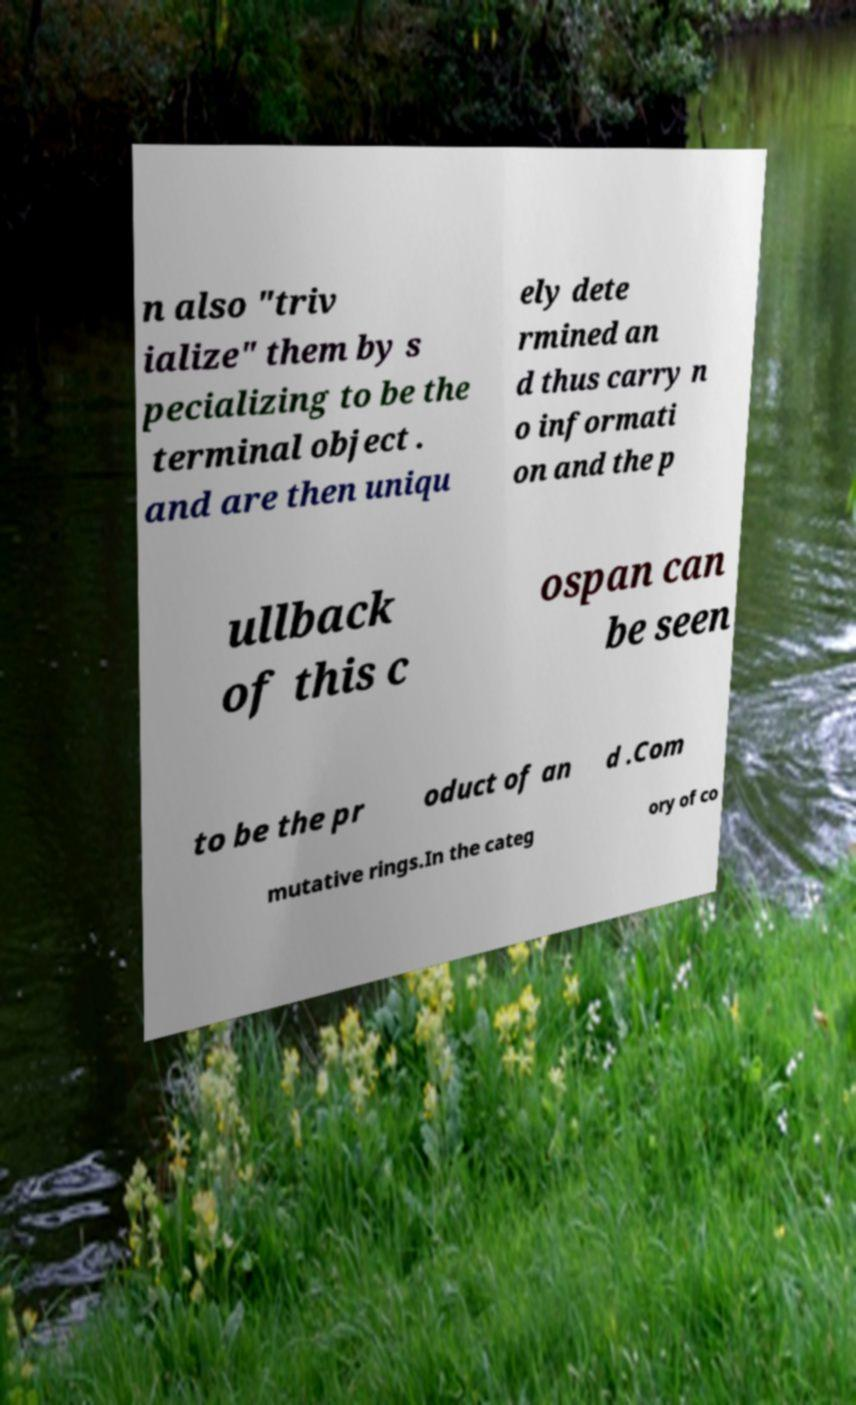Could you assist in decoding the text presented in this image and type it out clearly? n also "triv ialize" them by s pecializing to be the terminal object . and are then uniqu ely dete rmined an d thus carry n o informati on and the p ullback of this c ospan can be seen to be the pr oduct of an d .Com mutative rings.In the categ ory of co 